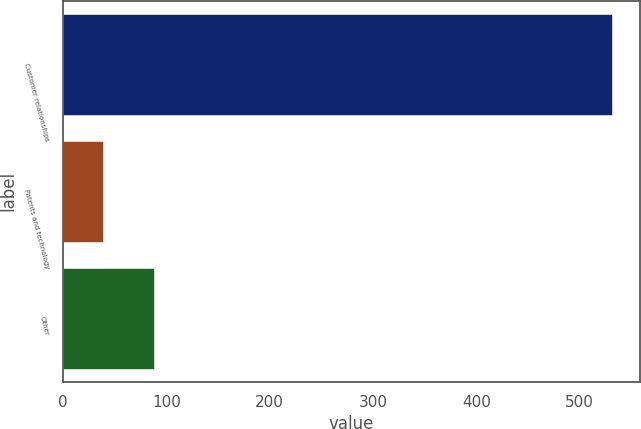Convert chart to OTSL. <chart><loc_0><loc_0><loc_500><loc_500><bar_chart><fcel>Customer relationships<fcel>Patents and technology<fcel>Other<nl><fcel>531.9<fcel>39.2<fcel>88.47<nl></chart> 